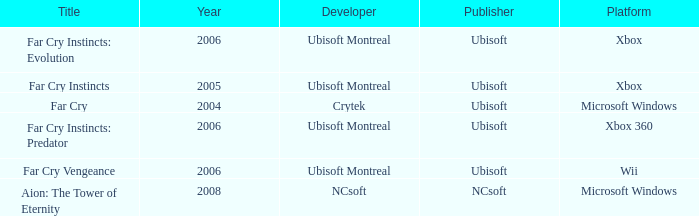Which title has xbox as the platform with a year prior to 2006? Far Cry Instincts. 